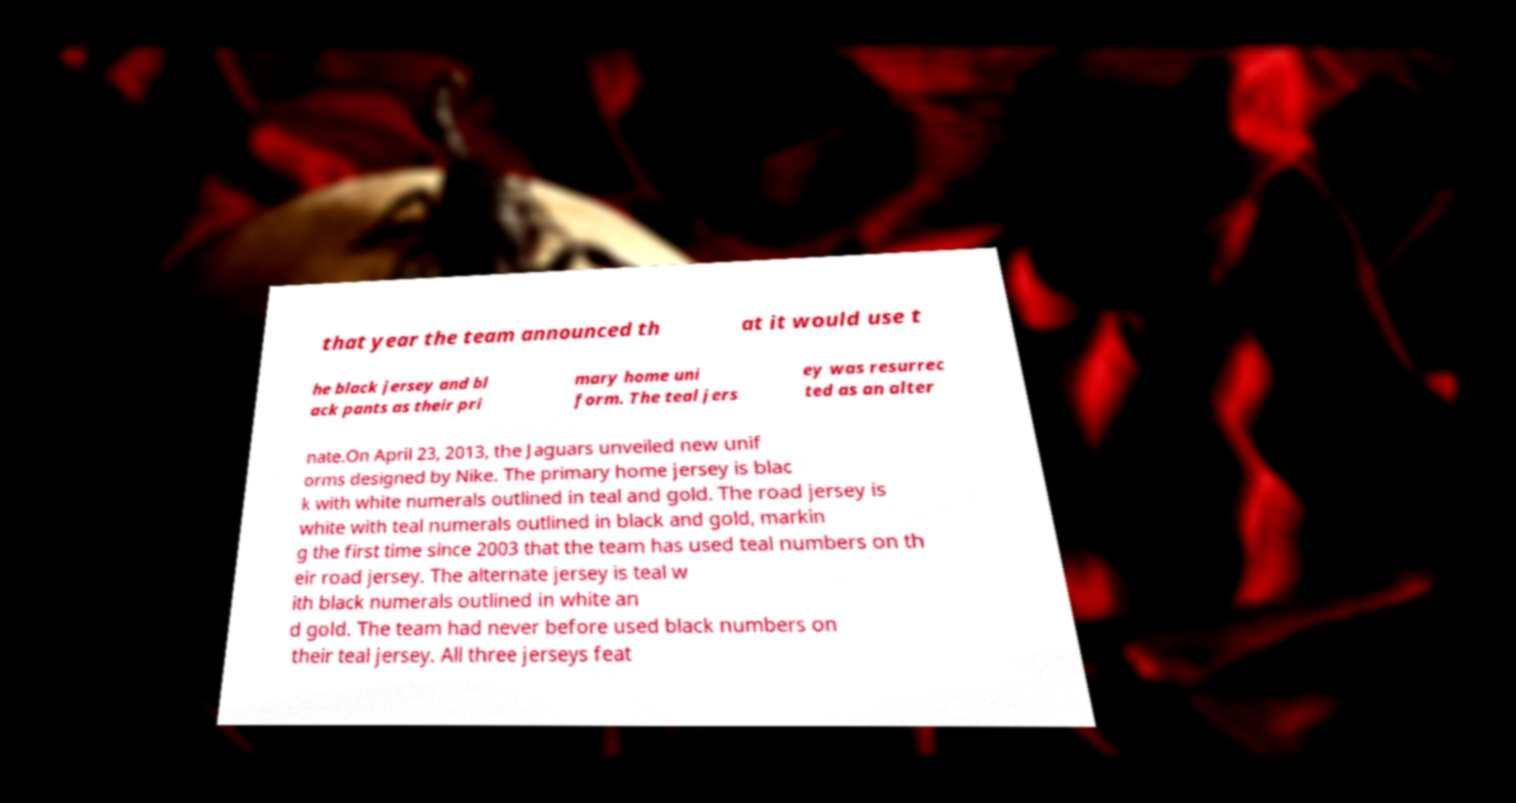Could you extract and type out the text from this image? that year the team announced th at it would use t he black jersey and bl ack pants as their pri mary home uni form. The teal jers ey was resurrec ted as an alter nate.On April 23, 2013, the Jaguars unveiled new unif orms designed by Nike. The primary home jersey is blac k with white numerals outlined in teal and gold. The road jersey is white with teal numerals outlined in black and gold, markin g the first time since 2003 that the team has used teal numbers on th eir road jersey. The alternate jersey is teal w ith black numerals outlined in white an d gold. The team had never before used black numbers on their teal jersey. All three jerseys feat 